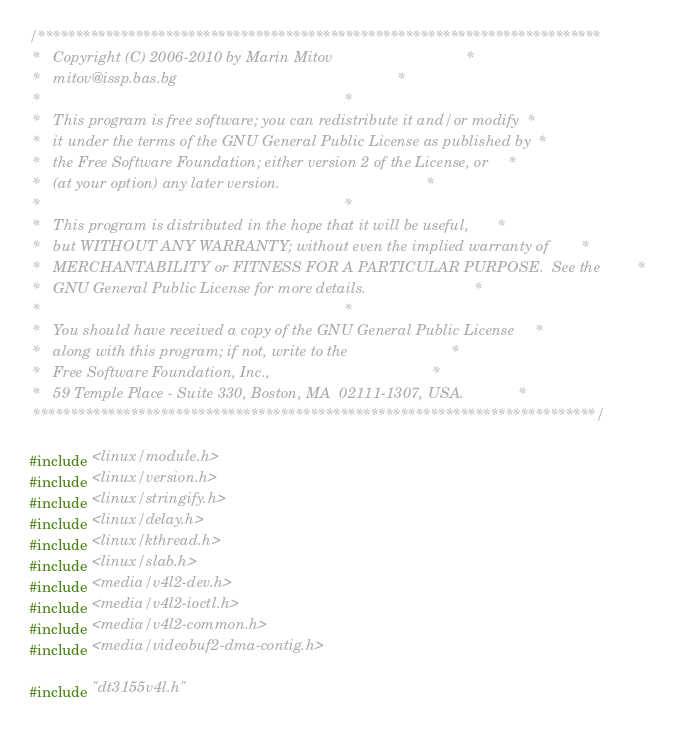<code> <loc_0><loc_0><loc_500><loc_500><_C_>/***************************************************************************
 *   Copyright (C) 2006-2010 by Marin Mitov                                *
 *   mitov@issp.bas.bg                                                     *
 *                                                                         *
 *   This program is free software; you can redistribute it and/or modify  *
 *   it under the terms of the GNU General Public License as published by  *
 *   the Free Software Foundation; either version 2 of the License, or     *
 *   (at your option) any later version.                                   *
 *                                                                         *
 *   This program is distributed in the hope that it will be useful,       *
 *   but WITHOUT ANY WARRANTY; without even the implied warranty of        *
 *   MERCHANTABILITY or FITNESS FOR A PARTICULAR PURPOSE.  See the         *
 *   GNU General Public License for more details.                          *
 *                                                                         *
 *   You should have received a copy of the GNU General Public License     *
 *   along with this program; if not, write to the                         *
 *   Free Software Foundation, Inc.,                                       *
 *   59 Temple Place - Suite 330, Boston, MA  02111-1307, USA.             *
 ***************************************************************************/

#include <linux/module.h>
#include <linux/version.h>
#include <linux/stringify.h>
#include <linux/delay.h>
#include <linux/kthread.h>
#include <linux/slab.h>
#include <media/v4l2-dev.h>
#include <media/v4l2-ioctl.h>
#include <media/v4l2-common.h>
#include <media/videobuf2-dma-contig.h>

#include "dt3155v4l.h"
</code> 